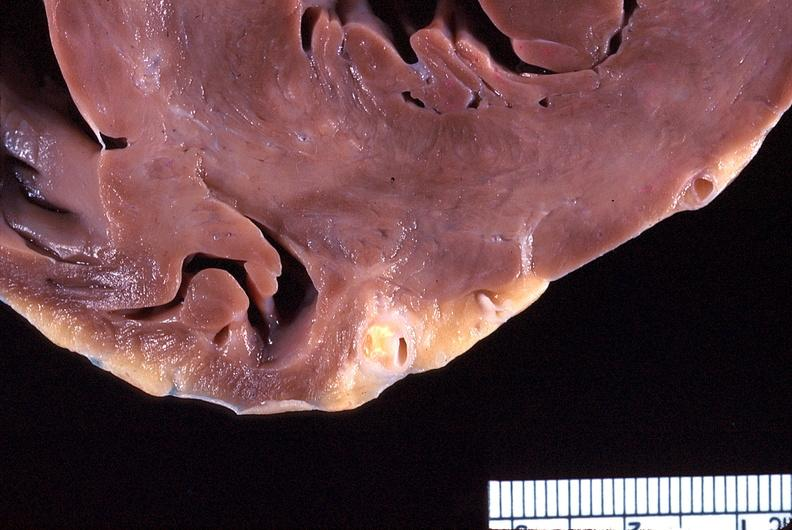does infant body show heart, coronary artery, atherosclerosis?
Answer the question using a single word or phrase. No 